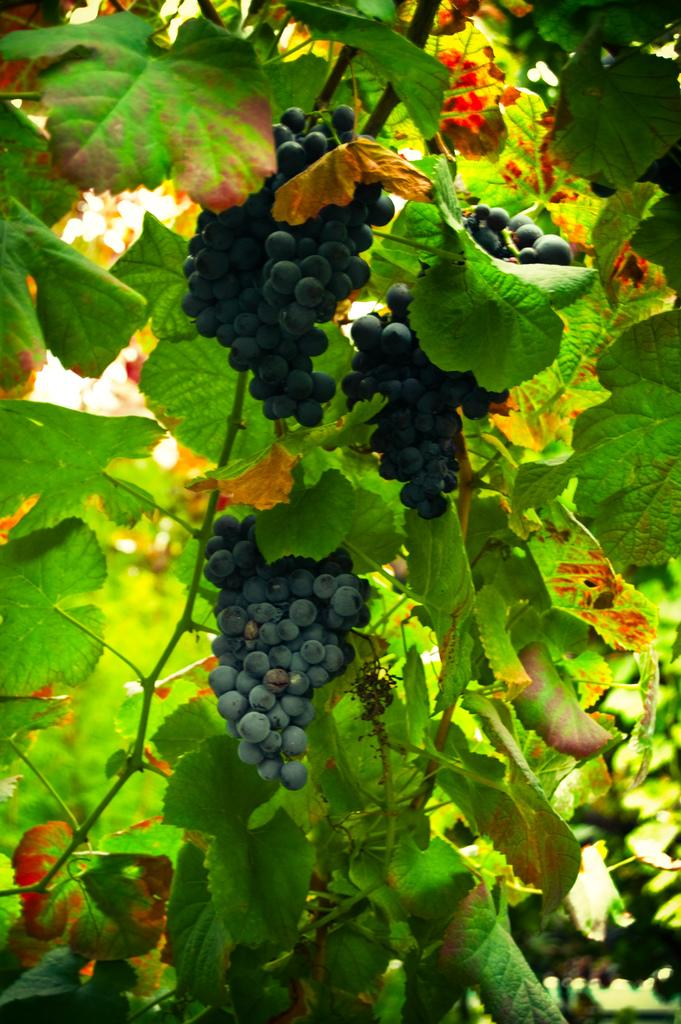What type of fruit is shown in the image? There are bunches of grapes in the image. How are the grapes attached to the tree? The grapes are hanging from stems in the image. What type of tree is depicted in the image? The image appears to depict a tree. What can be seen on the tree besides the grapes? There are leaves visible in the image. What is the color of the leaves on the tree? The leaves are green in color. What type of slope can be seen in the image? There is no slope present in the image; it depicts a tree with grapes and leaves. 